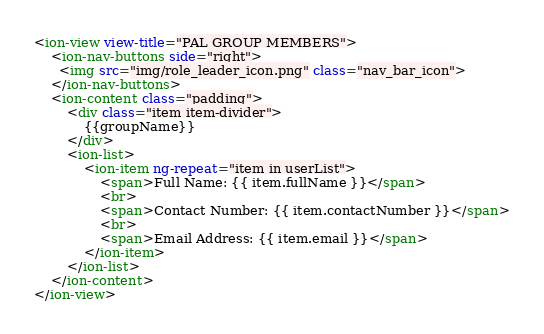Convert code to text. <code><loc_0><loc_0><loc_500><loc_500><_HTML_><ion-view view-title="PAL GROUP MEMBERS">
    <ion-nav-buttons side="right">
      <img src="img/role_leader_icon.png" class="nav_bar_icon">
	</ion-nav-buttons>
	<ion-content class="padding">
		<div class="item item-divider">
	    	{{groupName}}
	    </div>
	    <ion-list>
		    <ion-item ng-repeat="item in userList">
		    	<span>Full Name: {{ item.fullName }}</span>
		    	<br>
		    	<span>Contact Number: {{ item.contactNumber }}</span>
		    	<br>
		    	<span>Email Address: {{ item.email }}</span>
		    </ion-item>
	    </ion-list>
	</ion-content>
</ion-view></code> 